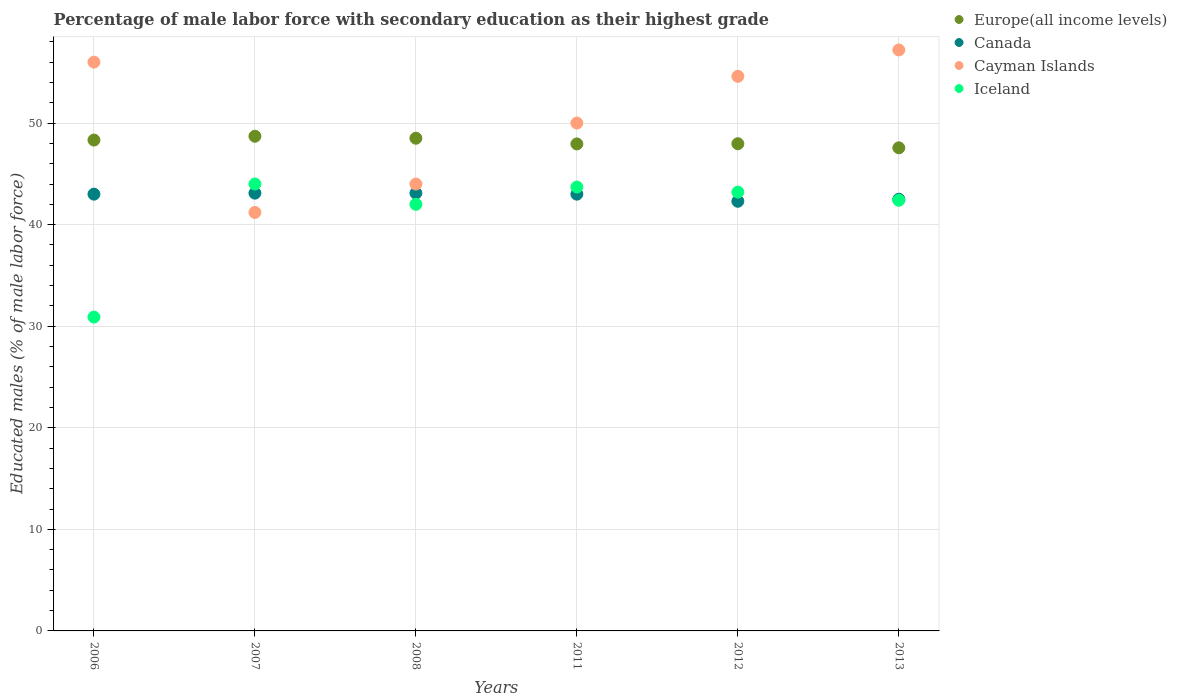How many different coloured dotlines are there?
Offer a terse response. 4. Is the number of dotlines equal to the number of legend labels?
Keep it short and to the point. Yes. What is the percentage of male labor force with secondary education in Europe(all income levels) in 2011?
Provide a short and direct response. 47.95. Across all years, what is the maximum percentage of male labor force with secondary education in Cayman Islands?
Provide a short and direct response. 57.2. Across all years, what is the minimum percentage of male labor force with secondary education in Cayman Islands?
Your answer should be very brief. 41.2. In which year was the percentage of male labor force with secondary education in Europe(all income levels) minimum?
Offer a terse response. 2013. What is the total percentage of male labor force with secondary education in Europe(all income levels) in the graph?
Provide a short and direct response. 289.01. What is the difference between the percentage of male labor force with secondary education in Europe(all income levels) in 2011 and the percentage of male labor force with secondary education in Cayman Islands in 2013?
Offer a very short reply. -9.25. What is the average percentage of male labor force with secondary education in Canada per year?
Give a very brief answer. 42.83. In the year 2011, what is the difference between the percentage of male labor force with secondary education in Europe(all income levels) and percentage of male labor force with secondary education in Iceland?
Your answer should be very brief. 4.25. What is the ratio of the percentage of male labor force with secondary education in Cayman Islands in 2007 to that in 2012?
Keep it short and to the point. 0.75. What is the difference between the highest and the second highest percentage of male labor force with secondary education in Cayman Islands?
Your response must be concise. 1.2. What is the difference between the highest and the lowest percentage of male labor force with secondary education in Iceland?
Provide a succinct answer. 13.1. Is the sum of the percentage of male labor force with secondary education in Europe(all income levels) in 2007 and 2008 greater than the maximum percentage of male labor force with secondary education in Cayman Islands across all years?
Your answer should be very brief. Yes. Is it the case that in every year, the sum of the percentage of male labor force with secondary education in Cayman Islands and percentage of male labor force with secondary education in Iceland  is greater than the sum of percentage of male labor force with secondary education in Europe(all income levels) and percentage of male labor force with secondary education in Canada?
Offer a very short reply. Yes. Is the percentage of male labor force with secondary education in Iceland strictly less than the percentage of male labor force with secondary education in Cayman Islands over the years?
Give a very brief answer. No. What is the difference between two consecutive major ticks on the Y-axis?
Provide a succinct answer. 10. Are the values on the major ticks of Y-axis written in scientific E-notation?
Your answer should be compact. No. What is the title of the graph?
Make the answer very short. Percentage of male labor force with secondary education as their highest grade. Does "Equatorial Guinea" appear as one of the legend labels in the graph?
Ensure brevity in your answer.  No. What is the label or title of the Y-axis?
Your answer should be very brief. Educated males (% of male labor force). What is the Educated males (% of male labor force) of Europe(all income levels) in 2006?
Offer a very short reply. 48.33. What is the Educated males (% of male labor force) of Canada in 2006?
Give a very brief answer. 43. What is the Educated males (% of male labor force) in Iceland in 2006?
Provide a short and direct response. 30.9. What is the Educated males (% of male labor force) in Europe(all income levels) in 2007?
Give a very brief answer. 48.7. What is the Educated males (% of male labor force) of Canada in 2007?
Your answer should be compact. 43.1. What is the Educated males (% of male labor force) of Cayman Islands in 2007?
Your answer should be very brief. 41.2. What is the Educated males (% of male labor force) of Europe(all income levels) in 2008?
Keep it short and to the point. 48.51. What is the Educated males (% of male labor force) of Canada in 2008?
Keep it short and to the point. 43.1. What is the Educated males (% of male labor force) of Europe(all income levels) in 2011?
Your answer should be compact. 47.95. What is the Educated males (% of male labor force) of Cayman Islands in 2011?
Give a very brief answer. 50. What is the Educated males (% of male labor force) in Iceland in 2011?
Provide a succinct answer. 43.7. What is the Educated males (% of male labor force) of Europe(all income levels) in 2012?
Give a very brief answer. 47.97. What is the Educated males (% of male labor force) in Canada in 2012?
Offer a very short reply. 42.3. What is the Educated males (% of male labor force) of Cayman Islands in 2012?
Make the answer very short. 54.6. What is the Educated males (% of male labor force) in Iceland in 2012?
Offer a very short reply. 43.2. What is the Educated males (% of male labor force) of Europe(all income levels) in 2013?
Provide a short and direct response. 47.56. What is the Educated males (% of male labor force) in Canada in 2013?
Your response must be concise. 42.5. What is the Educated males (% of male labor force) in Cayman Islands in 2013?
Make the answer very short. 57.2. What is the Educated males (% of male labor force) in Iceland in 2013?
Provide a short and direct response. 42.4. Across all years, what is the maximum Educated males (% of male labor force) in Europe(all income levels)?
Your response must be concise. 48.7. Across all years, what is the maximum Educated males (% of male labor force) of Canada?
Make the answer very short. 43.1. Across all years, what is the maximum Educated males (% of male labor force) of Cayman Islands?
Keep it short and to the point. 57.2. Across all years, what is the maximum Educated males (% of male labor force) of Iceland?
Your answer should be very brief. 44. Across all years, what is the minimum Educated males (% of male labor force) in Europe(all income levels)?
Keep it short and to the point. 47.56. Across all years, what is the minimum Educated males (% of male labor force) in Canada?
Offer a very short reply. 42.3. Across all years, what is the minimum Educated males (% of male labor force) of Cayman Islands?
Provide a succinct answer. 41.2. Across all years, what is the minimum Educated males (% of male labor force) in Iceland?
Offer a terse response. 30.9. What is the total Educated males (% of male labor force) in Europe(all income levels) in the graph?
Provide a succinct answer. 289.01. What is the total Educated males (% of male labor force) in Canada in the graph?
Provide a short and direct response. 257. What is the total Educated males (% of male labor force) in Cayman Islands in the graph?
Your answer should be very brief. 303. What is the total Educated males (% of male labor force) in Iceland in the graph?
Offer a terse response. 246.2. What is the difference between the Educated males (% of male labor force) of Europe(all income levels) in 2006 and that in 2007?
Your answer should be compact. -0.37. What is the difference between the Educated males (% of male labor force) of Canada in 2006 and that in 2007?
Your answer should be compact. -0.1. What is the difference between the Educated males (% of male labor force) in Europe(all income levels) in 2006 and that in 2008?
Give a very brief answer. -0.18. What is the difference between the Educated males (% of male labor force) of Canada in 2006 and that in 2008?
Give a very brief answer. -0.1. What is the difference between the Educated males (% of male labor force) of Iceland in 2006 and that in 2008?
Offer a very short reply. -11.1. What is the difference between the Educated males (% of male labor force) in Europe(all income levels) in 2006 and that in 2011?
Provide a succinct answer. 0.38. What is the difference between the Educated males (% of male labor force) in Iceland in 2006 and that in 2011?
Your answer should be very brief. -12.8. What is the difference between the Educated males (% of male labor force) of Europe(all income levels) in 2006 and that in 2012?
Offer a very short reply. 0.36. What is the difference between the Educated males (% of male labor force) in Cayman Islands in 2006 and that in 2012?
Provide a succinct answer. 1.4. What is the difference between the Educated males (% of male labor force) of Europe(all income levels) in 2006 and that in 2013?
Provide a short and direct response. 0.76. What is the difference between the Educated males (% of male labor force) in Canada in 2006 and that in 2013?
Provide a succinct answer. 0.5. What is the difference between the Educated males (% of male labor force) in Cayman Islands in 2006 and that in 2013?
Offer a very short reply. -1.2. What is the difference between the Educated males (% of male labor force) in Iceland in 2006 and that in 2013?
Provide a short and direct response. -11.5. What is the difference between the Educated males (% of male labor force) of Europe(all income levels) in 2007 and that in 2008?
Your answer should be compact. 0.19. What is the difference between the Educated males (% of male labor force) of Cayman Islands in 2007 and that in 2008?
Your response must be concise. -2.8. What is the difference between the Educated males (% of male labor force) of Iceland in 2007 and that in 2008?
Provide a succinct answer. 2. What is the difference between the Educated males (% of male labor force) in Europe(all income levels) in 2007 and that in 2011?
Your answer should be compact. 0.76. What is the difference between the Educated males (% of male labor force) of Canada in 2007 and that in 2011?
Your answer should be very brief. 0.1. What is the difference between the Educated males (% of male labor force) in Cayman Islands in 2007 and that in 2011?
Make the answer very short. -8.8. What is the difference between the Educated males (% of male labor force) in Iceland in 2007 and that in 2011?
Offer a terse response. 0.3. What is the difference between the Educated males (% of male labor force) in Europe(all income levels) in 2007 and that in 2012?
Keep it short and to the point. 0.74. What is the difference between the Educated males (% of male labor force) in Canada in 2007 and that in 2012?
Your answer should be compact. 0.8. What is the difference between the Educated males (% of male labor force) of Europe(all income levels) in 2007 and that in 2013?
Offer a terse response. 1.14. What is the difference between the Educated males (% of male labor force) of Iceland in 2007 and that in 2013?
Your response must be concise. 1.6. What is the difference between the Educated males (% of male labor force) of Europe(all income levels) in 2008 and that in 2011?
Offer a very short reply. 0.56. What is the difference between the Educated males (% of male labor force) of Cayman Islands in 2008 and that in 2011?
Keep it short and to the point. -6. What is the difference between the Educated males (% of male labor force) in Europe(all income levels) in 2008 and that in 2012?
Keep it short and to the point. 0.54. What is the difference between the Educated males (% of male labor force) in Europe(all income levels) in 2008 and that in 2013?
Make the answer very short. 0.94. What is the difference between the Educated males (% of male labor force) of Cayman Islands in 2008 and that in 2013?
Keep it short and to the point. -13.2. What is the difference between the Educated males (% of male labor force) in Iceland in 2008 and that in 2013?
Your answer should be compact. -0.4. What is the difference between the Educated males (% of male labor force) of Europe(all income levels) in 2011 and that in 2012?
Your answer should be compact. -0.02. What is the difference between the Educated males (% of male labor force) of Cayman Islands in 2011 and that in 2012?
Offer a very short reply. -4.6. What is the difference between the Educated males (% of male labor force) in Europe(all income levels) in 2011 and that in 2013?
Give a very brief answer. 0.38. What is the difference between the Educated males (% of male labor force) in Cayman Islands in 2011 and that in 2013?
Your response must be concise. -7.2. What is the difference between the Educated males (% of male labor force) in Iceland in 2011 and that in 2013?
Provide a short and direct response. 1.3. What is the difference between the Educated males (% of male labor force) of Europe(all income levels) in 2012 and that in 2013?
Offer a terse response. 0.4. What is the difference between the Educated males (% of male labor force) of Europe(all income levels) in 2006 and the Educated males (% of male labor force) of Canada in 2007?
Provide a succinct answer. 5.23. What is the difference between the Educated males (% of male labor force) of Europe(all income levels) in 2006 and the Educated males (% of male labor force) of Cayman Islands in 2007?
Your response must be concise. 7.13. What is the difference between the Educated males (% of male labor force) of Europe(all income levels) in 2006 and the Educated males (% of male labor force) of Iceland in 2007?
Make the answer very short. 4.33. What is the difference between the Educated males (% of male labor force) of Canada in 2006 and the Educated males (% of male labor force) of Cayman Islands in 2007?
Your response must be concise. 1.8. What is the difference between the Educated males (% of male labor force) of Cayman Islands in 2006 and the Educated males (% of male labor force) of Iceland in 2007?
Ensure brevity in your answer.  12. What is the difference between the Educated males (% of male labor force) in Europe(all income levels) in 2006 and the Educated males (% of male labor force) in Canada in 2008?
Offer a terse response. 5.23. What is the difference between the Educated males (% of male labor force) in Europe(all income levels) in 2006 and the Educated males (% of male labor force) in Cayman Islands in 2008?
Your response must be concise. 4.33. What is the difference between the Educated males (% of male labor force) of Europe(all income levels) in 2006 and the Educated males (% of male labor force) of Iceland in 2008?
Your response must be concise. 6.33. What is the difference between the Educated males (% of male labor force) of Canada in 2006 and the Educated males (% of male labor force) of Cayman Islands in 2008?
Provide a succinct answer. -1. What is the difference between the Educated males (% of male labor force) in Cayman Islands in 2006 and the Educated males (% of male labor force) in Iceland in 2008?
Provide a succinct answer. 14. What is the difference between the Educated males (% of male labor force) in Europe(all income levels) in 2006 and the Educated males (% of male labor force) in Canada in 2011?
Offer a terse response. 5.33. What is the difference between the Educated males (% of male labor force) of Europe(all income levels) in 2006 and the Educated males (% of male labor force) of Cayman Islands in 2011?
Give a very brief answer. -1.67. What is the difference between the Educated males (% of male labor force) of Europe(all income levels) in 2006 and the Educated males (% of male labor force) of Iceland in 2011?
Keep it short and to the point. 4.63. What is the difference between the Educated males (% of male labor force) of Europe(all income levels) in 2006 and the Educated males (% of male labor force) of Canada in 2012?
Your answer should be very brief. 6.03. What is the difference between the Educated males (% of male labor force) of Europe(all income levels) in 2006 and the Educated males (% of male labor force) of Cayman Islands in 2012?
Offer a terse response. -6.27. What is the difference between the Educated males (% of male labor force) of Europe(all income levels) in 2006 and the Educated males (% of male labor force) of Iceland in 2012?
Ensure brevity in your answer.  5.13. What is the difference between the Educated males (% of male labor force) of Canada in 2006 and the Educated males (% of male labor force) of Cayman Islands in 2012?
Make the answer very short. -11.6. What is the difference between the Educated males (% of male labor force) in Canada in 2006 and the Educated males (% of male labor force) in Iceland in 2012?
Ensure brevity in your answer.  -0.2. What is the difference between the Educated males (% of male labor force) of Cayman Islands in 2006 and the Educated males (% of male labor force) of Iceland in 2012?
Provide a succinct answer. 12.8. What is the difference between the Educated males (% of male labor force) of Europe(all income levels) in 2006 and the Educated males (% of male labor force) of Canada in 2013?
Your answer should be very brief. 5.83. What is the difference between the Educated males (% of male labor force) in Europe(all income levels) in 2006 and the Educated males (% of male labor force) in Cayman Islands in 2013?
Ensure brevity in your answer.  -8.87. What is the difference between the Educated males (% of male labor force) in Europe(all income levels) in 2006 and the Educated males (% of male labor force) in Iceland in 2013?
Offer a terse response. 5.93. What is the difference between the Educated males (% of male labor force) in Canada in 2006 and the Educated males (% of male labor force) in Cayman Islands in 2013?
Your answer should be very brief. -14.2. What is the difference between the Educated males (% of male labor force) in Canada in 2006 and the Educated males (% of male labor force) in Iceland in 2013?
Make the answer very short. 0.6. What is the difference between the Educated males (% of male labor force) in Europe(all income levels) in 2007 and the Educated males (% of male labor force) in Canada in 2008?
Ensure brevity in your answer.  5.6. What is the difference between the Educated males (% of male labor force) in Europe(all income levels) in 2007 and the Educated males (% of male labor force) in Cayman Islands in 2008?
Give a very brief answer. 4.7. What is the difference between the Educated males (% of male labor force) of Europe(all income levels) in 2007 and the Educated males (% of male labor force) of Iceland in 2008?
Your response must be concise. 6.7. What is the difference between the Educated males (% of male labor force) of Canada in 2007 and the Educated males (% of male labor force) of Cayman Islands in 2008?
Offer a terse response. -0.9. What is the difference between the Educated males (% of male labor force) of Europe(all income levels) in 2007 and the Educated males (% of male labor force) of Canada in 2011?
Your response must be concise. 5.7. What is the difference between the Educated males (% of male labor force) in Europe(all income levels) in 2007 and the Educated males (% of male labor force) in Cayman Islands in 2011?
Keep it short and to the point. -1.3. What is the difference between the Educated males (% of male labor force) of Europe(all income levels) in 2007 and the Educated males (% of male labor force) of Iceland in 2011?
Provide a short and direct response. 5. What is the difference between the Educated males (% of male labor force) of Canada in 2007 and the Educated males (% of male labor force) of Iceland in 2011?
Offer a terse response. -0.6. What is the difference between the Educated males (% of male labor force) in Europe(all income levels) in 2007 and the Educated males (% of male labor force) in Canada in 2012?
Provide a short and direct response. 6.4. What is the difference between the Educated males (% of male labor force) in Europe(all income levels) in 2007 and the Educated males (% of male labor force) in Cayman Islands in 2012?
Keep it short and to the point. -5.9. What is the difference between the Educated males (% of male labor force) of Europe(all income levels) in 2007 and the Educated males (% of male labor force) of Iceland in 2012?
Your answer should be very brief. 5.5. What is the difference between the Educated males (% of male labor force) in Europe(all income levels) in 2007 and the Educated males (% of male labor force) in Canada in 2013?
Your response must be concise. 6.2. What is the difference between the Educated males (% of male labor force) in Europe(all income levels) in 2007 and the Educated males (% of male labor force) in Cayman Islands in 2013?
Your answer should be compact. -8.5. What is the difference between the Educated males (% of male labor force) in Europe(all income levels) in 2007 and the Educated males (% of male labor force) in Iceland in 2013?
Your response must be concise. 6.3. What is the difference between the Educated males (% of male labor force) in Canada in 2007 and the Educated males (% of male labor force) in Cayman Islands in 2013?
Keep it short and to the point. -14.1. What is the difference between the Educated males (% of male labor force) in Canada in 2007 and the Educated males (% of male labor force) in Iceland in 2013?
Offer a terse response. 0.7. What is the difference between the Educated males (% of male labor force) in Europe(all income levels) in 2008 and the Educated males (% of male labor force) in Canada in 2011?
Your response must be concise. 5.51. What is the difference between the Educated males (% of male labor force) in Europe(all income levels) in 2008 and the Educated males (% of male labor force) in Cayman Islands in 2011?
Ensure brevity in your answer.  -1.49. What is the difference between the Educated males (% of male labor force) of Europe(all income levels) in 2008 and the Educated males (% of male labor force) of Iceland in 2011?
Provide a succinct answer. 4.81. What is the difference between the Educated males (% of male labor force) in Canada in 2008 and the Educated males (% of male labor force) in Iceland in 2011?
Give a very brief answer. -0.6. What is the difference between the Educated males (% of male labor force) in Cayman Islands in 2008 and the Educated males (% of male labor force) in Iceland in 2011?
Provide a short and direct response. 0.3. What is the difference between the Educated males (% of male labor force) in Europe(all income levels) in 2008 and the Educated males (% of male labor force) in Canada in 2012?
Your response must be concise. 6.21. What is the difference between the Educated males (% of male labor force) of Europe(all income levels) in 2008 and the Educated males (% of male labor force) of Cayman Islands in 2012?
Give a very brief answer. -6.09. What is the difference between the Educated males (% of male labor force) of Europe(all income levels) in 2008 and the Educated males (% of male labor force) of Iceland in 2012?
Your answer should be very brief. 5.31. What is the difference between the Educated males (% of male labor force) of Canada in 2008 and the Educated males (% of male labor force) of Iceland in 2012?
Your answer should be compact. -0.1. What is the difference between the Educated males (% of male labor force) in Europe(all income levels) in 2008 and the Educated males (% of male labor force) in Canada in 2013?
Give a very brief answer. 6.01. What is the difference between the Educated males (% of male labor force) of Europe(all income levels) in 2008 and the Educated males (% of male labor force) of Cayman Islands in 2013?
Offer a terse response. -8.69. What is the difference between the Educated males (% of male labor force) in Europe(all income levels) in 2008 and the Educated males (% of male labor force) in Iceland in 2013?
Provide a short and direct response. 6.11. What is the difference between the Educated males (% of male labor force) of Canada in 2008 and the Educated males (% of male labor force) of Cayman Islands in 2013?
Offer a very short reply. -14.1. What is the difference between the Educated males (% of male labor force) in Canada in 2008 and the Educated males (% of male labor force) in Iceland in 2013?
Give a very brief answer. 0.7. What is the difference between the Educated males (% of male labor force) in Cayman Islands in 2008 and the Educated males (% of male labor force) in Iceland in 2013?
Your response must be concise. 1.6. What is the difference between the Educated males (% of male labor force) of Europe(all income levels) in 2011 and the Educated males (% of male labor force) of Canada in 2012?
Make the answer very short. 5.65. What is the difference between the Educated males (% of male labor force) of Europe(all income levels) in 2011 and the Educated males (% of male labor force) of Cayman Islands in 2012?
Give a very brief answer. -6.65. What is the difference between the Educated males (% of male labor force) in Europe(all income levels) in 2011 and the Educated males (% of male labor force) in Iceland in 2012?
Ensure brevity in your answer.  4.75. What is the difference between the Educated males (% of male labor force) in Canada in 2011 and the Educated males (% of male labor force) in Cayman Islands in 2012?
Keep it short and to the point. -11.6. What is the difference between the Educated males (% of male labor force) of Canada in 2011 and the Educated males (% of male labor force) of Iceland in 2012?
Make the answer very short. -0.2. What is the difference between the Educated males (% of male labor force) in Cayman Islands in 2011 and the Educated males (% of male labor force) in Iceland in 2012?
Offer a very short reply. 6.8. What is the difference between the Educated males (% of male labor force) in Europe(all income levels) in 2011 and the Educated males (% of male labor force) in Canada in 2013?
Your answer should be compact. 5.45. What is the difference between the Educated males (% of male labor force) in Europe(all income levels) in 2011 and the Educated males (% of male labor force) in Cayman Islands in 2013?
Ensure brevity in your answer.  -9.25. What is the difference between the Educated males (% of male labor force) in Europe(all income levels) in 2011 and the Educated males (% of male labor force) in Iceland in 2013?
Give a very brief answer. 5.55. What is the difference between the Educated males (% of male labor force) in Europe(all income levels) in 2012 and the Educated males (% of male labor force) in Canada in 2013?
Provide a short and direct response. 5.47. What is the difference between the Educated males (% of male labor force) in Europe(all income levels) in 2012 and the Educated males (% of male labor force) in Cayman Islands in 2013?
Give a very brief answer. -9.23. What is the difference between the Educated males (% of male labor force) of Europe(all income levels) in 2012 and the Educated males (% of male labor force) of Iceland in 2013?
Keep it short and to the point. 5.57. What is the difference between the Educated males (% of male labor force) in Canada in 2012 and the Educated males (% of male labor force) in Cayman Islands in 2013?
Your answer should be compact. -14.9. What is the average Educated males (% of male labor force) of Europe(all income levels) per year?
Provide a short and direct response. 48.17. What is the average Educated males (% of male labor force) of Canada per year?
Your response must be concise. 42.83. What is the average Educated males (% of male labor force) in Cayman Islands per year?
Give a very brief answer. 50.5. What is the average Educated males (% of male labor force) in Iceland per year?
Your answer should be compact. 41.03. In the year 2006, what is the difference between the Educated males (% of male labor force) in Europe(all income levels) and Educated males (% of male labor force) in Canada?
Keep it short and to the point. 5.33. In the year 2006, what is the difference between the Educated males (% of male labor force) of Europe(all income levels) and Educated males (% of male labor force) of Cayman Islands?
Offer a very short reply. -7.67. In the year 2006, what is the difference between the Educated males (% of male labor force) in Europe(all income levels) and Educated males (% of male labor force) in Iceland?
Your answer should be very brief. 17.43. In the year 2006, what is the difference between the Educated males (% of male labor force) of Canada and Educated males (% of male labor force) of Cayman Islands?
Provide a succinct answer. -13. In the year 2006, what is the difference between the Educated males (% of male labor force) of Canada and Educated males (% of male labor force) of Iceland?
Ensure brevity in your answer.  12.1. In the year 2006, what is the difference between the Educated males (% of male labor force) in Cayman Islands and Educated males (% of male labor force) in Iceland?
Give a very brief answer. 25.1. In the year 2007, what is the difference between the Educated males (% of male labor force) of Europe(all income levels) and Educated males (% of male labor force) of Canada?
Make the answer very short. 5.6. In the year 2007, what is the difference between the Educated males (% of male labor force) of Europe(all income levels) and Educated males (% of male labor force) of Cayman Islands?
Keep it short and to the point. 7.5. In the year 2007, what is the difference between the Educated males (% of male labor force) of Europe(all income levels) and Educated males (% of male labor force) of Iceland?
Your answer should be very brief. 4.7. In the year 2008, what is the difference between the Educated males (% of male labor force) in Europe(all income levels) and Educated males (% of male labor force) in Canada?
Your answer should be compact. 5.41. In the year 2008, what is the difference between the Educated males (% of male labor force) of Europe(all income levels) and Educated males (% of male labor force) of Cayman Islands?
Make the answer very short. 4.51. In the year 2008, what is the difference between the Educated males (% of male labor force) in Europe(all income levels) and Educated males (% of male labor force) in Iceland?
Your answer should be compact. 6.51. In the year 2008, what is the difference between the Educated males (% of male labor force) in Canada and Educated males (% of male labor force) in Iceland?
Ensure brevity in your answer.  1.1. In the year 2008, what is the difference between the Educated males (% of male labor force) in Cayman Islands and Educated males (% of male labor force) in Iceland?
Offer a terse response. 2. In the year 2011, what is the difference between the Educated males (% of male labor force) of Europe(all income levels) and Educated males (% of male labor force) of Canada?
Offer a very short reply. 4.95. In the year 2011, what is the difference between the Educated males (% of male labor force) in Europe(all income levels) and Educated males (% of male labor force) in Cayman Islands?
Give a very brief answer. -2.05. In the year 2011, what is the difference between the Educated males (% of male labor force) in Europe(all income levels) and Educated males (% of male labor force) in Iceland?
Make the answer very short. 4.25. In the year 2012, what is the difference between the Educated males (% of male labor force) in Europe(all income levels) and Educated males (% of male labor force) in Canada?
Give a very brief answer. 5.67. In the year 2012, what is the difference between the Educated males (% of male labor force) in Europe(all income levels) and Educated males (% of male labor force) in Cayman Islands?
Give a very brief answer. -6.63. In the year 2012, what is the difference between the Educated males (% of male labor force) of Europe(all income levels) and Educated males (% of male labor force) of Iceland?
Ensure brevity in your answer.  4.77. In the year 2012, what is the difference between the Educated males (% of male labor force) in Canada and Educated males (% of male labor force) in Cayman Islands?
Your response must be concise. -12.3. In the year 2013, what is the difference between the Educated males (% of male labor force) of Europe(all income levels) and Educated males (% of male labor force) of Canada?
Keep it short and to the point. 5.06. In the year 2013, what is the difference between the Educated males (% of male labor force) in Europe(all income levels) and Educated males (% of male labor force) in Cayman Islands?
Your response must be concise. -9.64. In the year 2013, what is the difference between the Educated males (% of male labor force) in Europe(all income levels) and Educated males (% of male labor force) in Iceland?
Offer a terse response. 5.16. In the year 2013, what is the difference between the Educated males (% of male labor force) in Canada and Educated males (% of male labor force) in Cayman Islands?
Ensure brevity in your answer.  -14.7. In the year 2013, what is the difference between the Educated males (% of male labor force) of Canada and Educated males (% of male labor force) of Iceland?
Provide a short and direct response. 0.1. In the year 2013, what is the difference between the Educated males (% of male labor force) of Cayman Islands and Educated males (% of male labor force) of Iceland?
Ensure brevity in your answer.  14.8. What is the ratio of the Educated males (% of male labor force) in Europe(all income levels) in 2006 to that in 2007?
Give a very brief answer. 0.99. What is the ratio of the Educated males (% of male labor force) in Cayman Islands in 2006 to that in 2007?
Your answer should be compact. 1.36. What is the ratio of the Educated males (% of male labor force) in Iceland in 2006 to that in 2007?
Your response must be concise. 0.7. What is the ratio of the Educated males (% of male labor force) in Europe(all income levels) in 2006 to that in 2008?
Your response must be concise. 1. What is the ratio of the Educated males (% of male labor force) of Cayman Islands in 2006 to that in 2008?
Your response must be concise. 1.27. What is the ratio of the Educated males (% of male labor force) of Iceland in 2006 to that in 2008?
Ensure brevity in your answer.  0.74. What is the ratio of the Educated males (% of male labor force) of Europe(all income levels) in 2006 to that in 2011?
Offer a terse response. 1.01. What is the ratio of the Educated males (% of male labor force) of Canada in 2006 to that in 2011?
Provide a short and direct response. 1. What is the ratio of the Educated males (% of male labor force) in Cayman Islands in 2006 to that in 2011?
Provide a succinct answer. 1.12. What is the ratio of the Educated males (% of male labor force) in Iceland in 2006 to that in 2011?
Your answer should be very brief. 0.71. What is the ratio of the Educated males (% of male labor force) in Europe(all income levels) in 2006 to that in 2012?
Offer a terse response. 1.01. What is the ratio of the Educated males (% of male labor force) of Canada in 2006 to that in 2012?
Your response must be concise. 1.02. What is the ratio of the Educated males (% of male labor force) in Cayman Islands in 2006 to that in 2012?
Give a very brief answer. 1.03. What is the ratio of the Educated males (% of male labor force) of Iceland in 2006 to that in 2012?
Ensure brevity in your answer.  0.72. What is the ratio of the Educated males (% of male labor force) of Europe(all income levels) in 2006 to that in 2013?
Ensure brevity in your answer.  1.02. What is the ratio of the Educated males (% of male labor force) of Canada in 2006 to that in 2013?
Keep it short and to the point. 1.01. What is the ratio of the Educated males (% of male labor force) in Iceland in 2006 to that in 2013?
Your response must be concise. 0.73. What is the ratio of the Educated males (% of male labor force) of Europe(all income levels) in 2007 to that in 2008?
Keep it short and to the point. 1. What is the ratio of the Educated males (% of male labor force) in Canada in 2007 to that in 2008?
Provide a short and direct response. 1. What is the ratio of the Educated males (% of male labor force) in Cayman Islands in 2007 to that in 2008?
Your answer should be compact. 0.94. What is the ratio of the Educated males (% of male labor force) in Iceland in 2007 to that in 2008?
Your answer should be very brief. 1.05. What is the ratio of the Educated males (% of male labor force) of Europe(all income levels) in 2007 to that in 2011?
Your answer should be very brief. 1.02. What is the ratio of the Educated males (% of male labor force) in Canada in 2007 to that in 2011?
Your response must be concise. 1. What is the ratio of the Educated males (% of male labor force) in Cayman Islands in 2007 to that in 2011?
Your answer should be very brief. 0.82. What is the ratio of the Educated males (% of male labor force) in Iceland in 2007 to that in 2011?
Keep it short and to the point. 1.01. What is the ratio of the Educated males (% of male labor force) of Europe(all income levels) in 2007 to that in 2012?
Your answer should be compact. 1.02. What is the ratio of the Educated males (% of male labor force) in Canada in 2007 to that in 2012?
Provide a short and direct response. 1.02. What is the ratio of the Educated males (% of male labor force) of Cayman Islands in 2007 to that in 2012?
Your answer should be very brief. 0.75. What is the ratio of the Educated males (% of male labor force) of Iceland in 2007 to that in 2012?
Offer a terse response. 1.02. What is the ratio of the Educated males (% of male labor force) of Europe(all income levels) in 2007 to that in 2013?
Give a very brief answer. 1.02. What is the ratio of the Educated males (% of male labor force) in Canada in 2007 to that in 2013?
Make the answer very short. 1.01. What is the ratio of the Educated males (% of male labor force) in Cayman Islands in 2007 to that in 2013?
Your answer should be compact. 0.72. What is the ratio of the Educated males (% of male labor force) in Iceland in 2007 to that in 2013?
Offer a very short reply. 1.04. What is the ratio of the Educated males (% of male labor force) of Europe(all income levels) in 2008 to that in 2011?
Keep it short and to the point. 1.01. What is the ratio of the Educated males (% of male labor force) in Canada in 2008 to that in 2011?
Give a very brief answer. 1. What is the ratio of the Educated males (% of male labor force) in Iceland in 2008 to that in 2011?
Keep it short and to the point. 0.96. What is the ratio of the Educated males (% of male labor force) of Europe(all income levels) in 2008 to that in 2012?
Give a very brief answer. 1.01. What is the ratio of the Educated males (% of male labor force) in Canada in 2008 to that in 2012?
Make the answer very short. 1.02. What is the ratio of the Educated males (% of male labor force) of Cayman Islands in 2008 to that in 2012?
Offer a very short reply. 0.81. What is the ratio of the Educated males (% of male labor force) in Iceland in 2008 to that in 2012?
Your answer should be very brief. 0.97. What is the ratio of the Educated males (% of male labor force) in Europe(all income levels) in 2008 to that in 2013?
Provide a short and direct response. 1.02. What is the ratio of the Educated males (% of male labor force) in Canada in 2008 to that in 2013?
Your answer should be compact. 1.01. What is the ratio of the Educated males (% of male labor force) of Cayman Islands in 2008 to that in 2013?
Your response must be concise. 0.77. What is the ratio of the Educated males (% of male labor force) in Iceland in 2008 to that in 2013?
Your answer should be compact. 0.99. What is the ratio of the Educated males (% of male labor force) in Europe(all income levels) in 2011 to that in 2012?
Offer a very short reply. 1. What is the ratio of the Educated males (% of male labor force) of Canada in 2011 to that in 2012?
Make the answer very short. 1.02. What is the ratio of the Educated males (% of male labor force) in Cayman Islands in 2011 to that in 2012?
Your answer should be compact. 0.92. What is the ratio of the Educated males (% of male labor force) in Iceland in 2011 to that in 2012?
Offer a very short reply. 1.01. What is the ratio of the Educated males (% of male labor force) of Canada in 2011 to that in 2013?
Provide a succinct answer. 1.01. What is the ratio of the Educated males (% of male labor force) in Cayman Islands in 2011 to that in 2013?
Your response must be concise. 0.87. What is the ratio of the Educated males (% of male labor force) of Iceland in 2011 to that in 2013?
Keep it short and to the point. 1.03. What is the ratio of the Educated males (% of male labor force) in Europe(all income levels) in 2012 to that in 2013?
Make the answer very short. 1.01. What is the ratio of the Educated males (% of male labor force) in Canada in 2012 to that in 2013?
Provide a short and direct response. 1. What is the ratio of the Educated males (% of male labor force) of Cayman Islands in 2012 to that in 2013?
Your answer should be compact. 0.95. What is the ratio of the Educated males (% of male labor force) in Iceland in 2012 to that in 2013?
Keep it short and to the point. 1.02. What is the difference between the highest and the second highest Educated males (% of male labor force) in Europe(all income levels)?
Keep it short and to the point. 0.19. What is the difference between the highest and the second highest Educated males (% of male labor force) in Iceland?
Provide a succinct answer. 0.3. What is the difference between the highest and the lowest Educated males (% of male labor force) of Europe(all income levels)?
Provide a succinct answer. 1.14. What is the difference between the highest and the lowest Educated males (% of male labor force) in Canada?
Offer a very short reply. 0.8. What is the difference between the highest and the lowest Educated males (% of male labor force) in Iceland?
Your answer should be very brief. 13.1. 